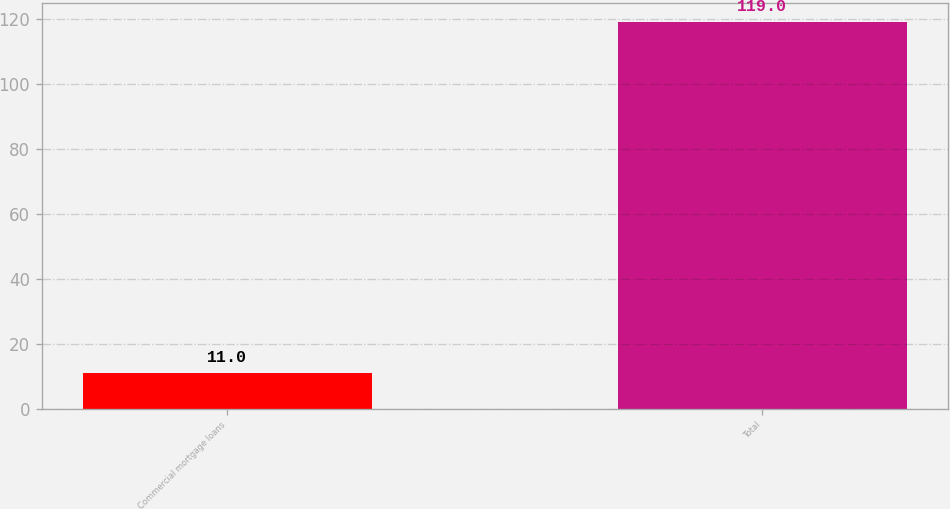<chart> <loc_0><loc_0><loc_500><loc_500><bar_chart><fcel>Commercial mortgage loans<fcel>Total<nl><fcel>11<fcel>119<nl></chart> 